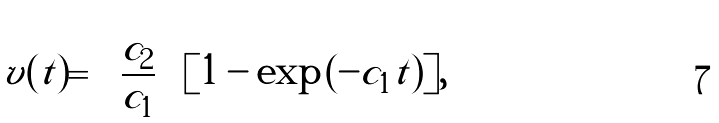<formula> <loc_0><loc_0><loc_500><loc_500>v ( t ) = \left ( \frac { c _ { 2 } } { c _ { 1 } } \right ) [ 1 - \exp { ( - c _ { 1 } t ) } ] ,</formula> 